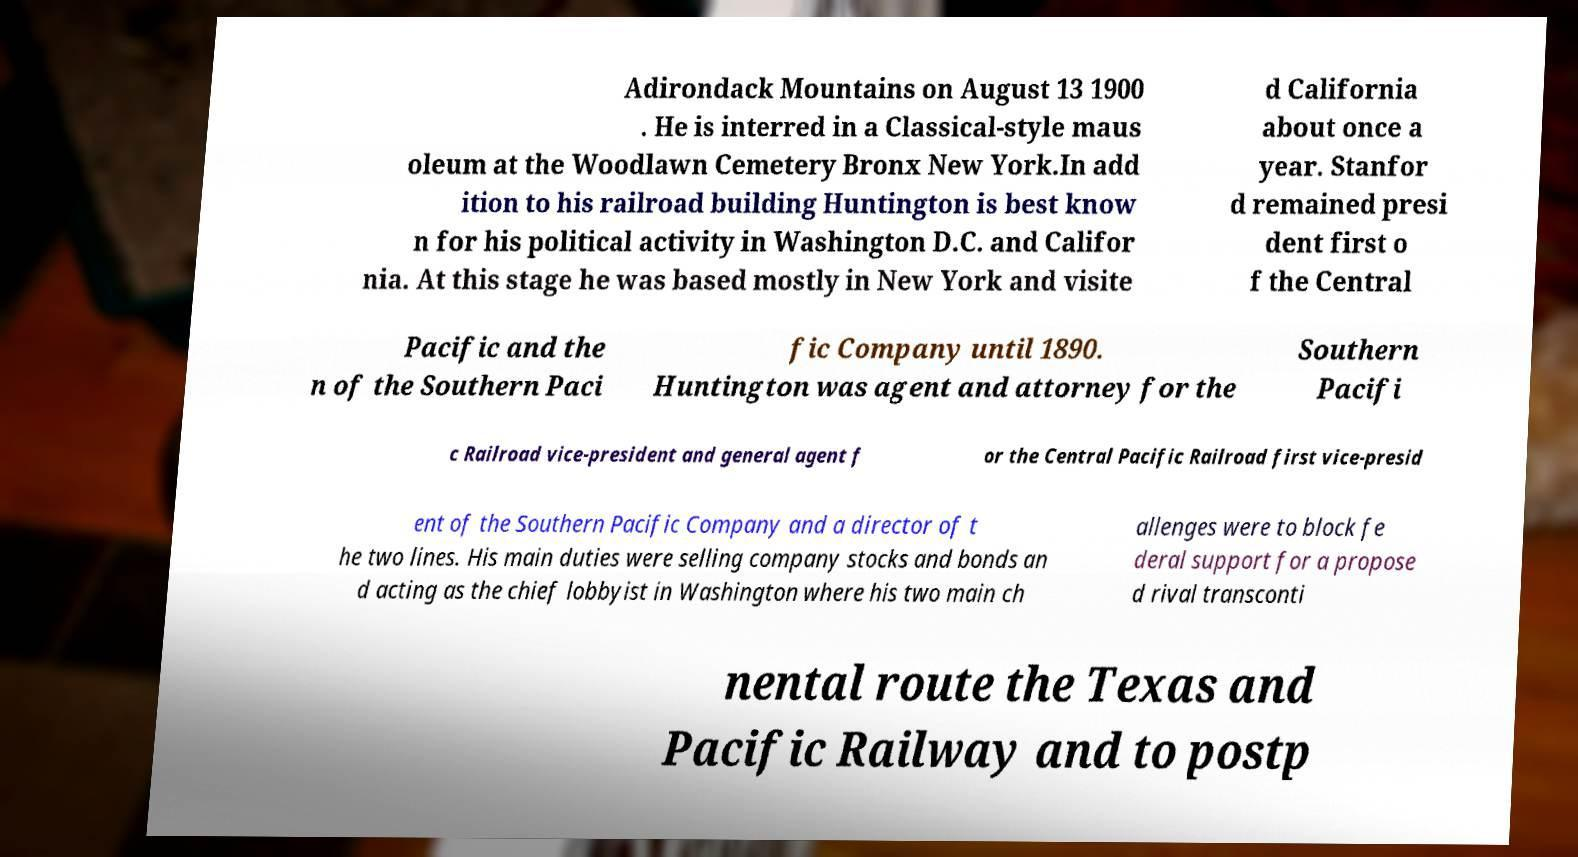Please identify and transcribe the text found in this image. Adirondack Mountains on August 13 1900 . He is interred in a Classical-style maus oleum at the Woodlawn Cemetery Bronx New York.In add ition to his railroad building Huntington is best know n for his political activity in Washington D.C. and Califor nia. At this stage he was based mostly in New York and visite d California about once a year. Stanfor d remained presi dent first o f the Central Pacific and the n of the Southern Paci fic Company until 1890. Huntington was agent and attorney for the Southern Pacifi c Railroad vice-president and general agent f or the Central Pacific Railroad first vice-presid ent of the Southern Pacific Company and a director of t he two lines. His main duties were selling company stocks and bonds an d acting as the chief lobbyist in Washington where his two main ch allenges were to block fe deral support for a propose d rival transconti nental route the Texas and Pacific Railway and to postp 